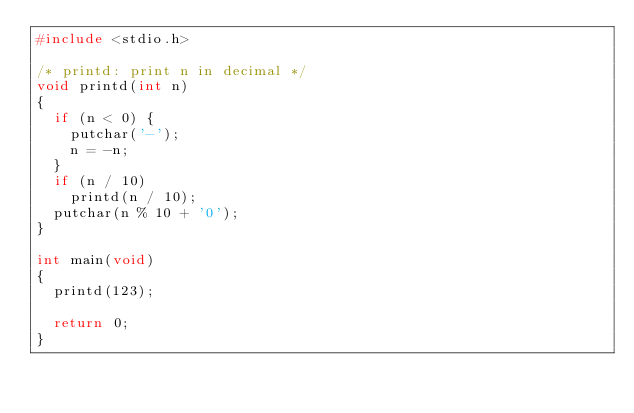<code> <loc_0><loc_0><loc_500><loc_500><_C_>#include <stdio.h>

/* printd: print n in decimal */
void printd(int n)
{
  if (n < 0) {
    putchar('-');
    n = -n;
  }
  if (n / 10)
    printd(n / 10);
  putchar(n % 10 + '0');
}

int main(void)
{
  printd(123);

  return 0;
}
</code> 